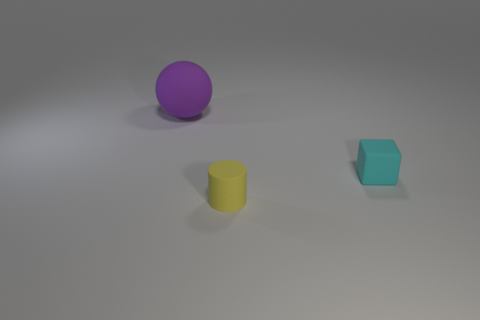How many other things are the same material as the large purple ball?
Make the answer very short. 2. Are the ball behind the yellow matte cylinder and the tiny thing that is behind the tiny yellow matte thing made of the same material?
Ensure brevity in your answer.  Yes. Is there anything else that has the same shape as the yellow rubber object?
Give a very brief answer. No. Do the small cyan object and the thing that is on the left side of the matte cylinder have the same material?
Offer a very short reply. Yes. What color is the thing behind the object to the right of the yellow matte thing in front of the tiny cyan block?
Offer a very short reply. Purple. There is another rubber object that is the same size as the yellow matte object; what is its shape?
Ensure brevity in your answer.  Cube. Is there anything else that has the same size as the matte cube?
Provide a succinct answer. Yes. There is a thing that is right of the tiny cylinder; is its size the same as the matte object behind the tiny matte block?
Provide a succinct answer. No. What is the size of the rubber ball that is left of the tiny rubber cylinder?
Offer a terse response. Large. What color is the cube that is the same size as the yellow cylinder?
Make the answer very short. Cyan. 